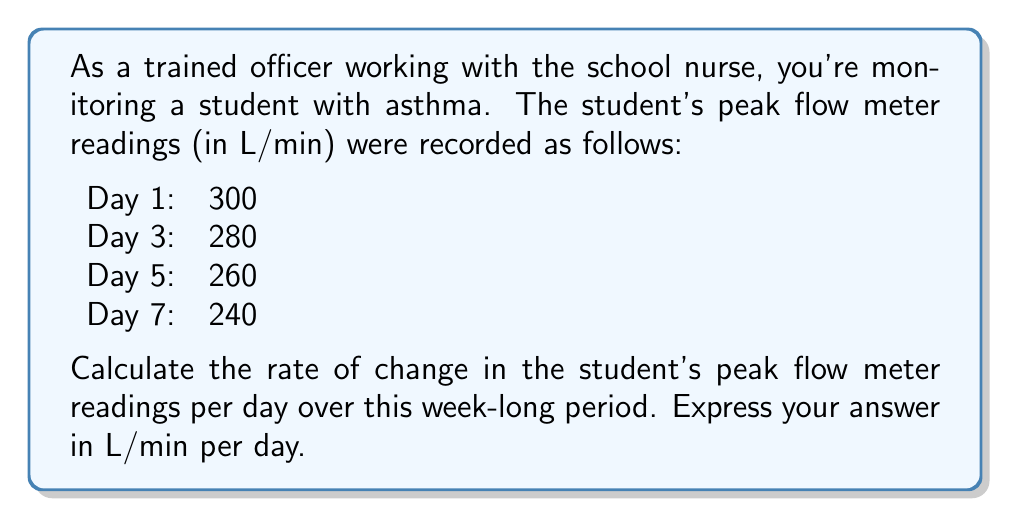Can you solve this math problem? To calculate the rate of change, we need to use the slope formula:

$$ \text{Rate of change} = \frac{\text{Change in y}}{\text{Change in x}} = \frac{\Delta y}{\Delta x} $$

In this case:
- $y$ represents the peak flow meter readings (in L/min)
- $x$ represents the days

Let's use the first and last data points to calculate the overall rate of change:

Initial reading (Day 1): $y_1 = 300$ L/min
Final reading (Day 7): $y_2 = 240$ L/min
Time period: $\Delta x = 7 - 1 = 6$ days

Now, let's plug these values into the formula:

$$ \text{Rate of change} = \frac{\Delta y}{\Delta x} = \frac{y_2 - y_1}{x_2 - x_1} = \frac{240 - 300}{7 - 1} = \frac{-60}{6} = -10 $$

The negative value indicates a decrease in the peak flow meter readings over time.
Answer: The rate of change in the student's peak flow meter readings is $-10$ L/min per day. 